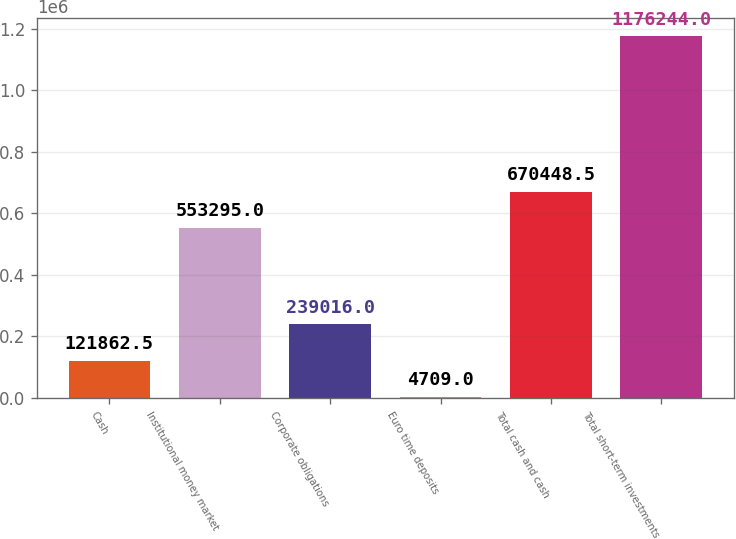Convert chart. <chart><loc_0><loc_0><loc_500><loc_500><bar_chart><fcel>Cash<fcel>Institutional money market<fcel>Corporate obligations<fcel>Euro time deposits<fcel>Total cash and cash<fcel>Total short-term investments<nl><fcel>121862<fcel>553295<fcel>239016<fcel>4709<fcel>670448<fcel>1.17624e+06<nl></chart> 